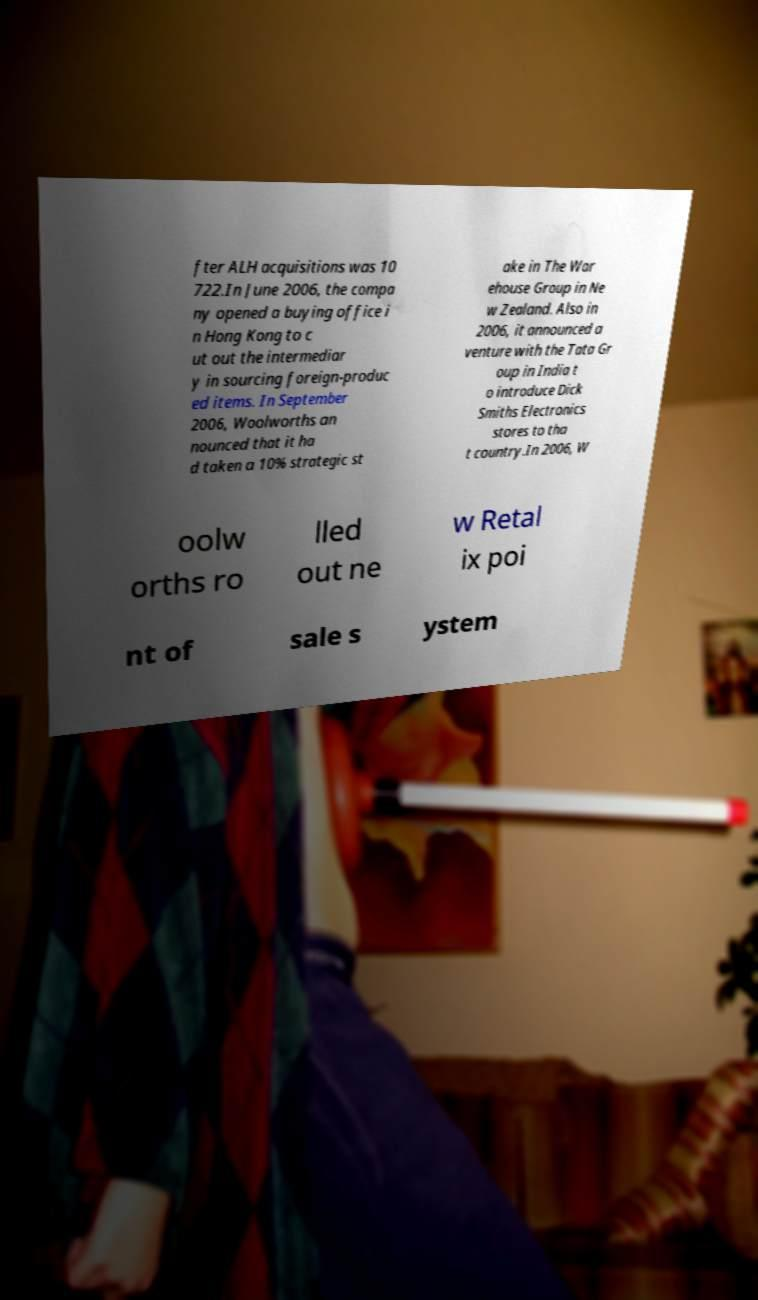Can you read and provide the text displayed in the image?This photo seems to have some interesting text. Can you extract and type it out for me? fter ALH acquisitions was 10 722.In June 2006, the compa ny opened a buying office i n Hong Kong to c ut out the intermediar y in sourcing foreign-produc ed items. In September 2006, Woolworths an nounced that it ha d taken a 10% strategic st ake in The War ehouse Group in Ne w Zealand. Also in 2006, it announced a venture with the Tata Gr oup in India t o introduce Dick Smiths Electronics stores to tha t country.In 2006, W oolw orths ro lled out ne w Retal ix poi nt of sale s ystem 